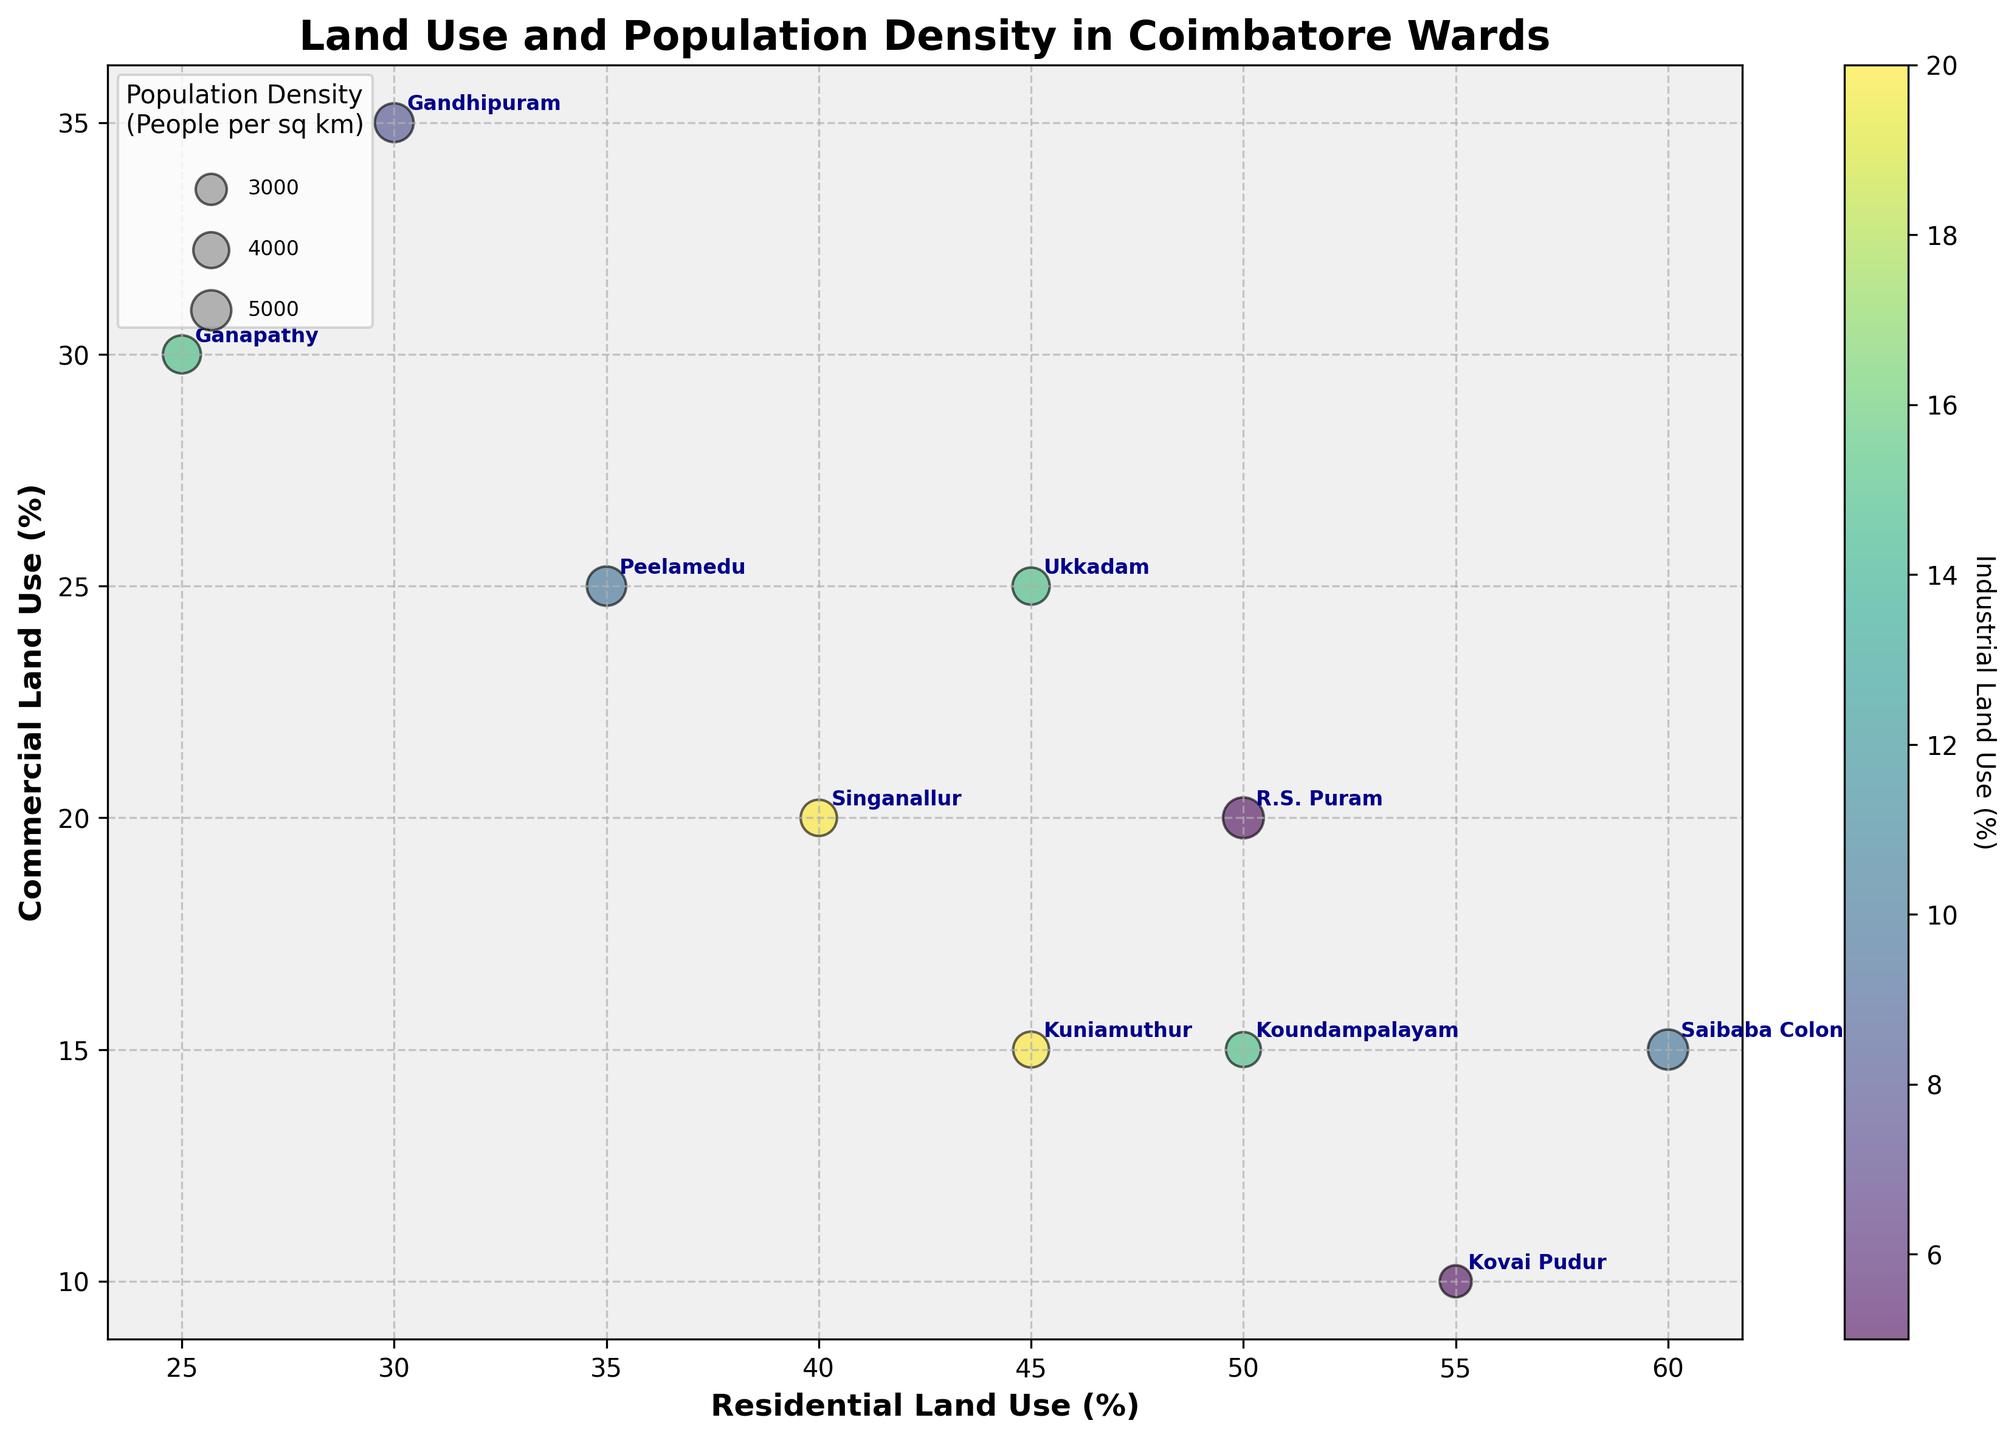What's the title of the chart? The title of the chart is written at the top center of the figure.
Answer: Land Use and Population Density in Coimbatore Wards What are the x and y axes representing? The labels for the axes state what they represent: the x-axis indicates 'Residential Land Use (%)' and the y-axis indicates 'Commercial Land Use (%)'.
Answer: Residential Land Use (%) and Commercial Land Use (%) How many wards have a Residential Land Use (%) of over 50%? By observing the x-axis and locating the bubbles to the right of the 50% mark, we count the number of corresponding bubbles.
Answer: 4 Which ward has the highest Population Density (People per sq km)? By noting the largest bubble size, and checking the annotated ward, we find it is 'R.S. Puram'.
Answer: R.S. Puram Compare the Industrial Land Use (%) between Ganapathy and Gandhipuram. Which one is higher? The color of the bubbles and the color bar indicate Industrial Land Use (%). Gandhipuram has a darker color compared to Ganapathy, showing a higher Industrial Land Use.
Answer: Gandhipuram Which ward has the smallest bubble size and what does it indicate? The smallest bubble represents the lowest Population Density (People per sq km). By checking the smallest bubble with its annotation, we find it is 'Kovai Pudur'.
Answer: Kovai Pudur What's the relationship between Residential Land Use (%) and Commercial Land Use (%) in R.S. Puram? The x-axis shows Residential Land Use, and the y-axis shows Commercial Land Use. For R.S. Puram, the coordinates on the scatter plot determine these values.
Answer: 50% Residential and 20% Commercial How many wards have an Industrial Land Use (%) above 15% and what are they? Using the color bar as a reference for Industrial Land Use (%), identify and count bubbles with the corresponding darker shades, and then note their annotations.
Answer: 4; Ganapathy, Singanallur, Ukkadam, Kuniamuthur What's the range of Commercial Land Use (%) displayed in the chart? By looking at the minimum and maximum values along the y-axis, we determine the range of Commercial Land Use (%).
Answer: 10% to 35% What's the sum of Residential and Commercial Land Use (%) for Peelamedu? Identify the coordinates of Peelamedu, sum the x-axis value (Residential Land Use) and y-axis value (Commercial Land Use): 35% + 25%.
Answer: 60% 